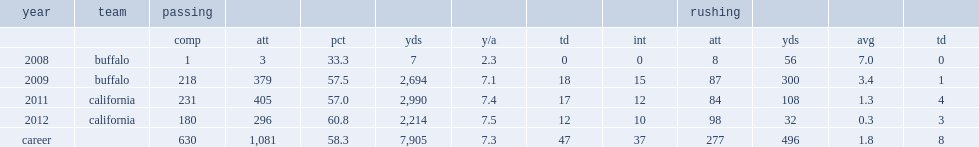How many passing yards did maynard get in 2011? 2990.0. 